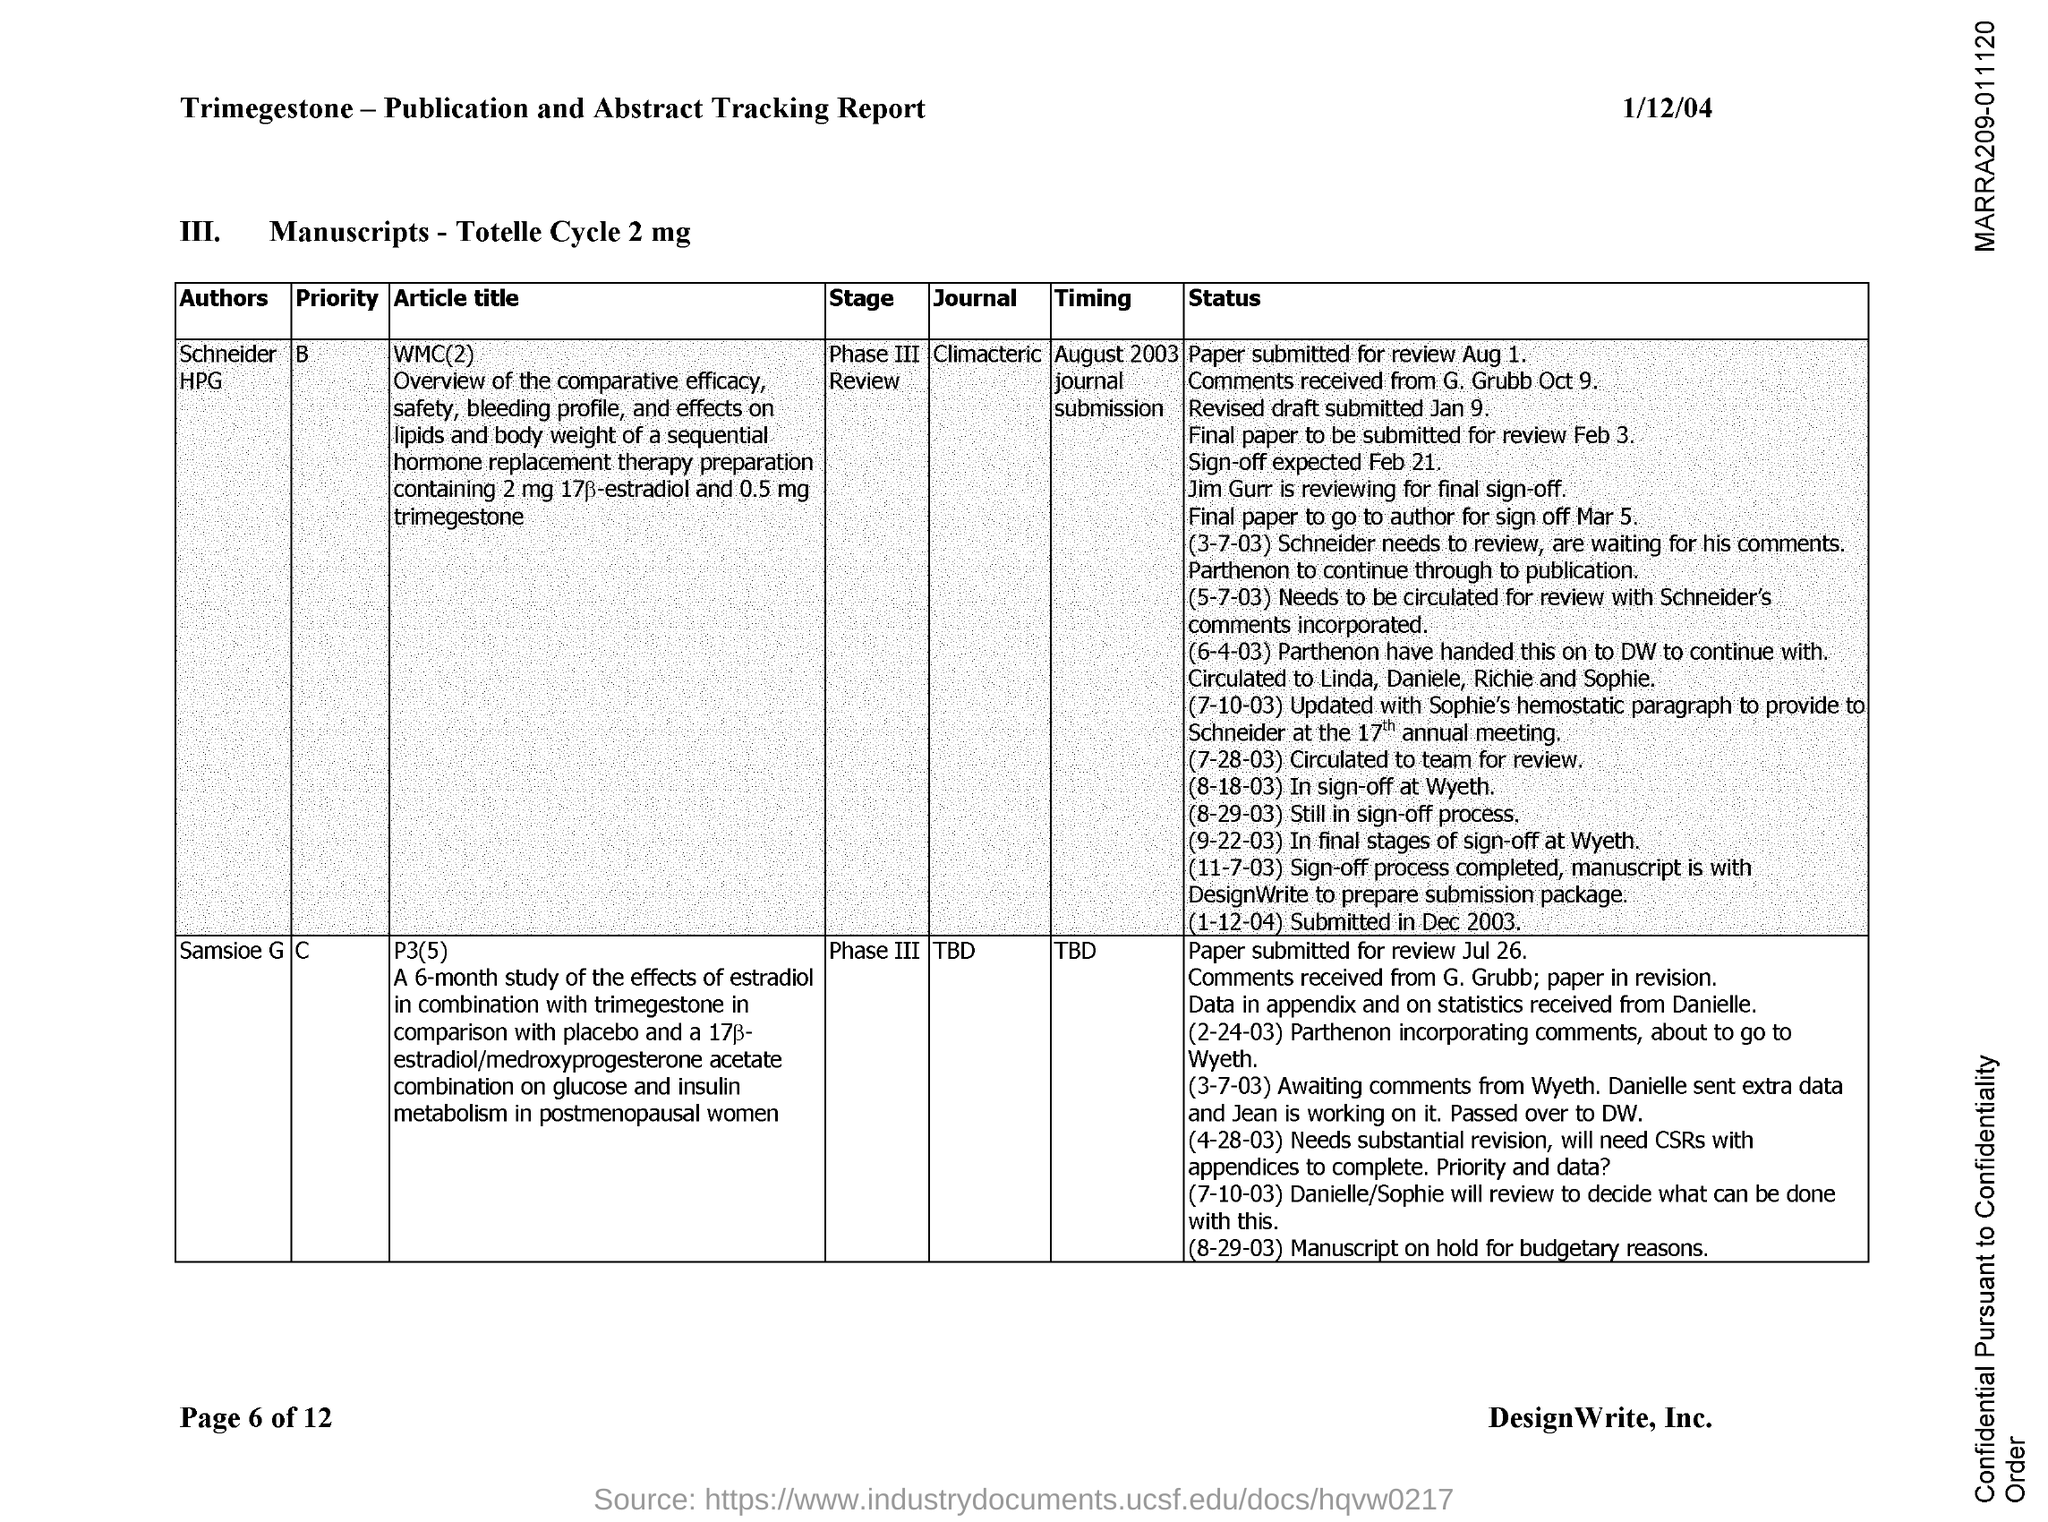Highlight a few significant elements in this photo. On what date was WMC(2) conducted in August 2003? The document is dated 1/12/04. The stage of P3(5) is Phase III. WMC(2) was authored by Schneider HPG. 